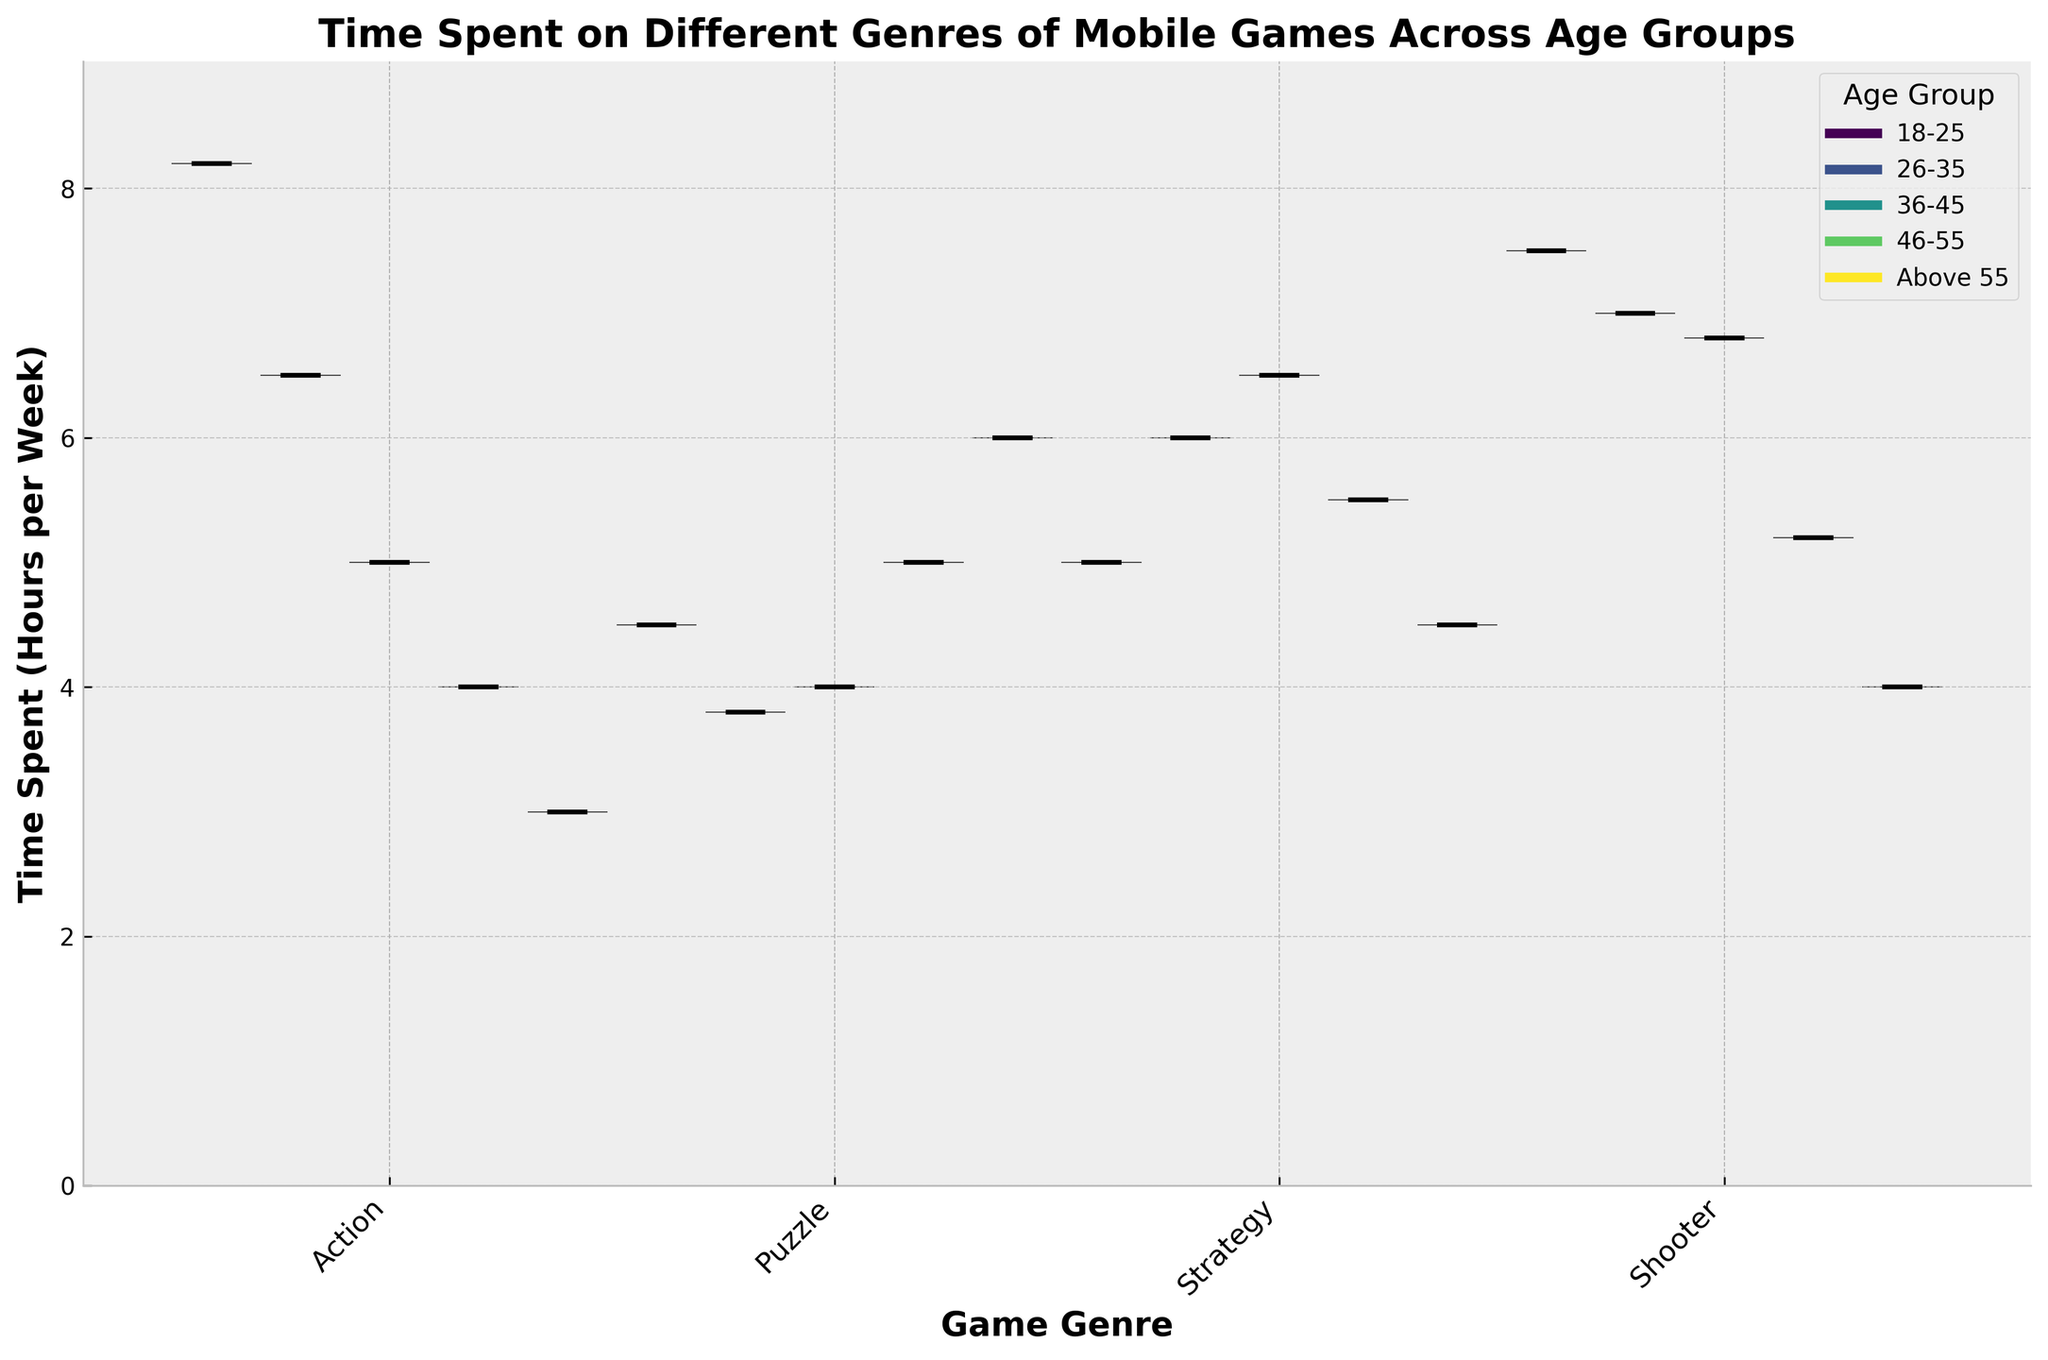What is the title of the chart? The title of the chart is usually located at the top and provides a summary of what the chart represents. In this case, it shows the time spent on different genres of mobile games across age groups.
Answer: Time Spent on Different Genres of Mobile Games Across Age Groups Which genre has the highest median time spent by the 18-25 age group? To find the answer, look at the position of the median line (the central line) within the violins for the 18-25 age group, which are the slightly shifted violins to the left. Compare the median lines across different genres.
Answer: Action What is the general trend in time spent on Puzzle games as age increases? Examine the median lines' positions for the Puzzle game genre across different age groups from 18-25 to Above 55. A rising trend indicates increasing time spent as age progresses.
Answer: Increases How does the time spent on Strategy games by the 26-35 age group compare to the 18-25 age group? Compare the positions of the median lines in the violins for Strategy games between the 26-35 and the 18-25 age groups. Determine whether one is higher or lower than the other.
Answer: Higher Which age group spends the least amount of time on Shooter games? Look for the violin with the lowest median line within the Shooter genre across all age groups. The violin plot for the age group with the lowest median line shows this information.
Answer: Above 55 What is the range of time spent on Action games for the 36-45 age group? Identify the widest span from the bottom to the top of the 36-45 age group's Action game violin. This represents the range.
Answer: 5.0 Which genre shows the most significant decrease in median time spent as age increases from 18-25 to Above 55? Compare the median lines across all genres from age group 18-25 to Above 55. Identify which genre's median line drops the most over these age groups.
Answer: Action Is the median time spent on Shooter games consistently decreasing with age? Track the positions of the median lines for Shooter games across all age groups. Consistent decrease means each subsequent age group has a lower median line than the previous one.
Answer: Yes Which age group has the most variation in time spent on Strategy games? To determine the variation, look for the violin plot with the most spread (widest span from bottom to top) for Strategy games among all age groups.
Answer: 36-45 